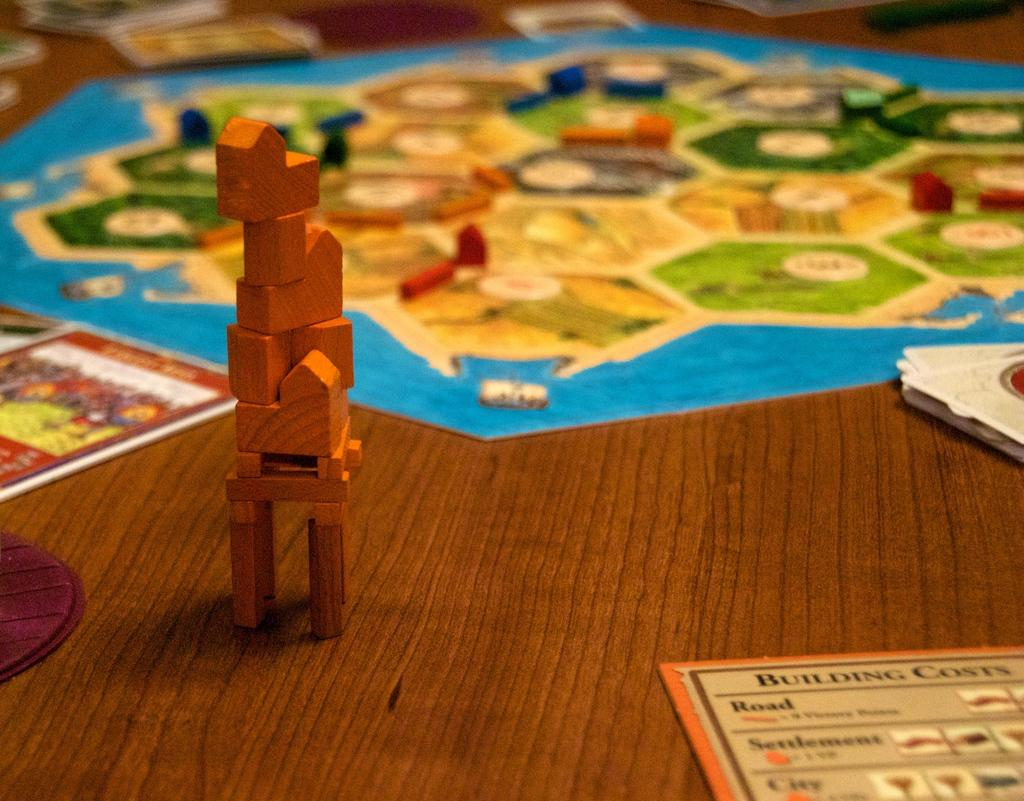<image>
Summarize the visual content of the image. Board game with building pieces and instructions for Building Costs. 